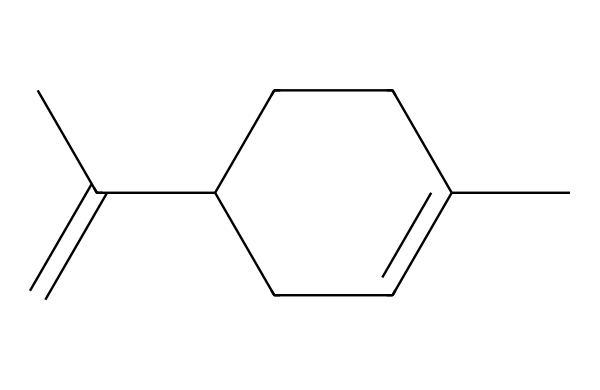What is the molecular formula of limonene? By analyzing the SMILES representation, we count the number of carbon (C) and hydrogen (H) atoms present. The structure shows 10 carbon atoms and 16 hydrogen atoms, leading to the molecular formula C10H16.
Answer: C10H16 How many rings are present in this compound? The structure represented does not exhibit any ring connections. Therefore, upon visual inspection of the SMILES, we conclude that there are zero rings in limonene.
Answer: 0 Does limonene display aromatic characteristics? To determine if it is aromatic, we check for a cyclic structure with alternating double bonds and adhering to Huckel's rule. Limonene has a non-aromatic cyclic part and no complete resonance stabilization of the benzene type. Thus, it is not classified as aromatic.
Answer: No What type of hydrocarbon is limonene classified as? The structure has a specific arrangement of carbon atoms with respect to hydrogen that designates it as a terpene, specifically a monoterpene, since it has 10 carbon atoms.
Answer: monoterpene What is the hybridization of the carbon atoms involved in the double bond? The presence of a double bond in the structure indicates that the involved carbon atoms undergo sp2 hybridization, as they are part of a pi-bonded system, allowing for planar geometry around those carbons.
Answer: sp2 How many double bonds are in limonene? From the SMILES representation, we can see that there are two double bonds indicated (C=C), occurring in the structural layout. This gives us a total of 2 double bonds in limonene.
Answer: 2 